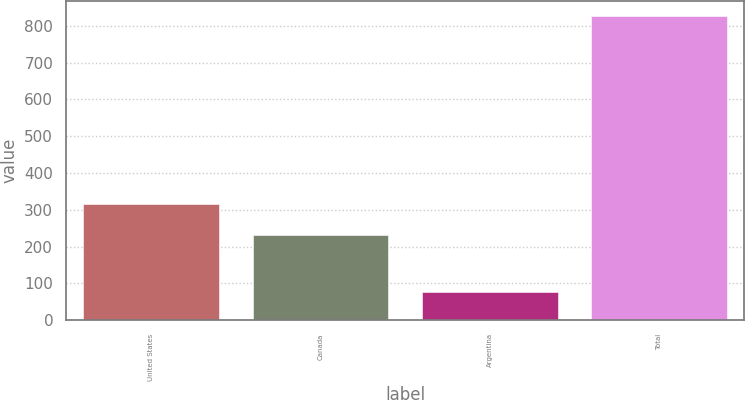Convert chart. <chart><loc_0><loc_0><loc_500><loc_500><bar_chart><fcel>United States<fcel>Canada<fcel>Argentina<fcel>Total<nl><fcel>315.6<fcel>230.9<fcel>77.5<fcel>825.8<nl></chart> 